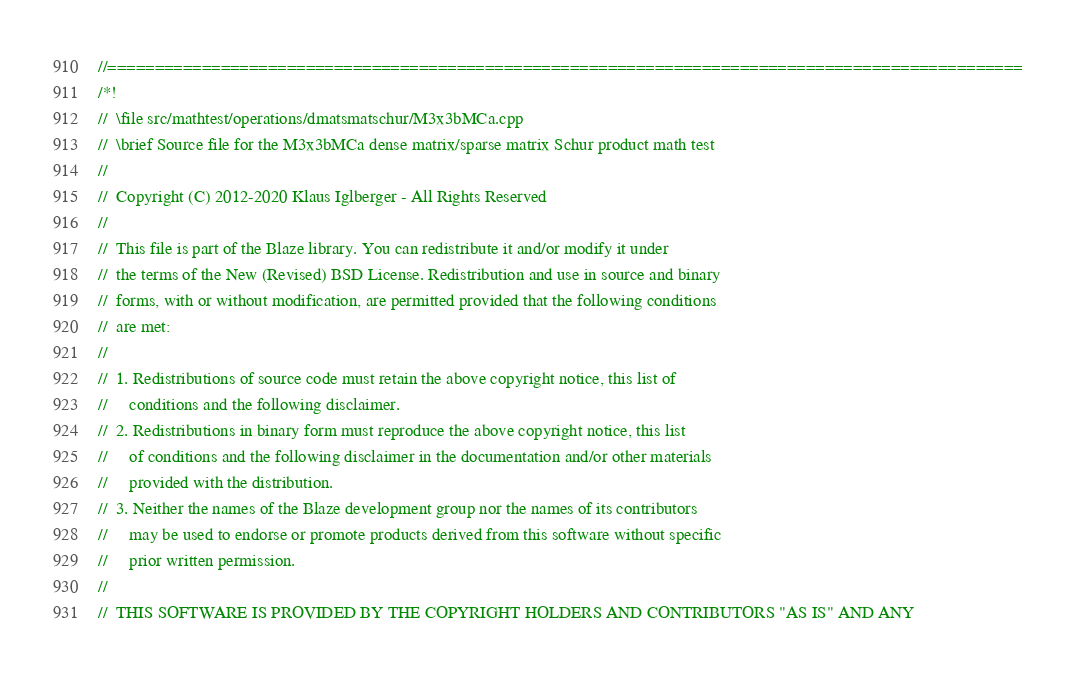<code> <loc_0><loc_0><loc_500><loc_500><_C++_>//=================================================================================================
/*!
//  \file src/mathtest/operations/dmatsmatschur/M3x3bMCa.cpp
//  \brief Source file for the M3x3bMCa dense matrix/sparse matrix Schur product math test
//
//  Copyright (C) 2012-2020 Klaus Iglberger - All Rights Reserved
//
//  This file is part of the Blaze library. You can redistribute it and/or modify it under
//  the terms of the New (Revised) BSD License. Redistribution and use in source and binary
//  forms, with or without modification, are permitted provided that the following conditions
//  are met:
//
//  1. Redistributions of source code must retain the above copyright notice, this list of
//     conditions and the following disclaimer.
//  2. Redistributions in binary form must reproduce the above copyright notice, this list
//     of conditions and the following disclaimer in the documentation and/or other materials
//     provided with the distribution.
//  3. Neither the names of the Blaze development group nor the names of its contributors
//     may be used to endorse or promote products derived from this software without specific
//     prior written permission.
//
//  THIS SOFTWARE IS PROVIDED BY THE COPYRIGHT HOLDERS AND CONTRIBUTORS "AS IS" AND ANY</code> 